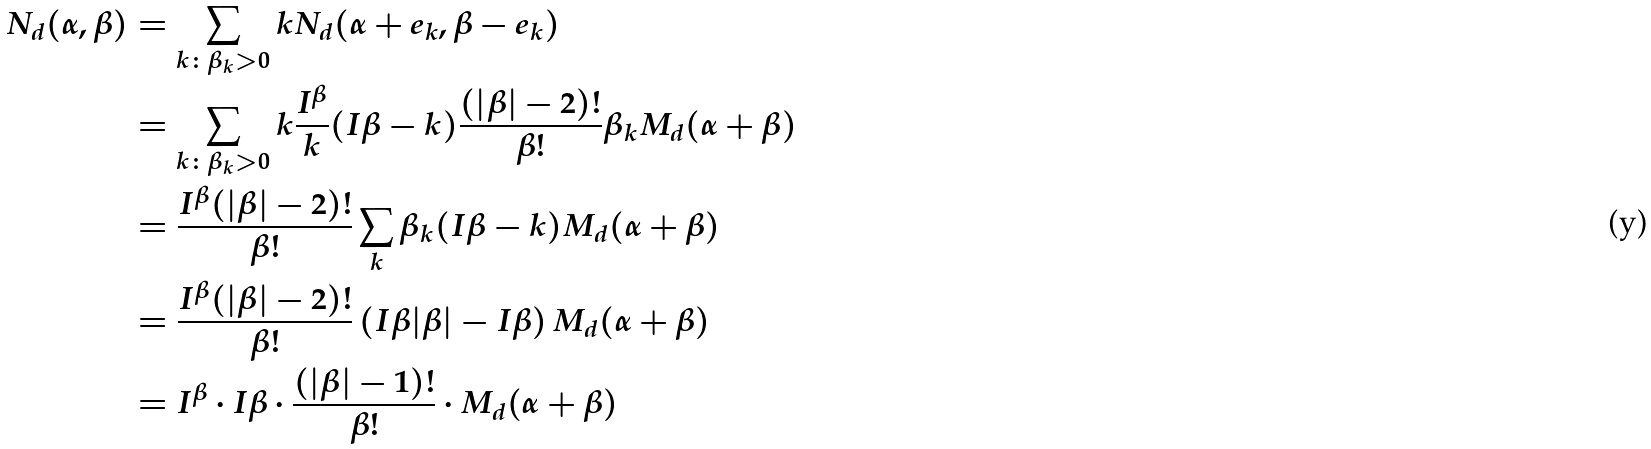<formula> <loc_0><loc_0><loc_500><loc_500>N _ { d } ( \alpha , \beta ) & = \sum _ { k \colon \beta _ { k } > 0 } k N _ { d } ( \alpha + e _ { k } , \beta - e _ { k } ) \\ & = \sum _ { k \colon \beta _ { k } > 0 } k \frac { I ^ { \beta } } { k } ( I \beta - k ) \frac { ( | \beta | - 2 ) ! } { \beta ! } \beta _ { k } M _ { d } ( \alpha + \beta ) \\ & = \frac { I ^ { \beta } ( | \beta | - 2 ) ! } { \beta ! } \sum _ { k } \beta _ { k } ( I \beta - k ) M _ { d } ( \alpha + \beta ) \\ & = \frac { I ^ { \beta } ( | \beta | - 2 ) ! } { \beta ! } \left ( I \beta | \beta | - I \beta \right ) M _ { d } ( \alpha + \beta ) \\ & = I ^ { \beta } \cdot I \beta \cdot \frac { ( | \beta | - 1 ) ! } { \beta ! } \cdot M _ { d } ( \alpha + \beta )</formula> 